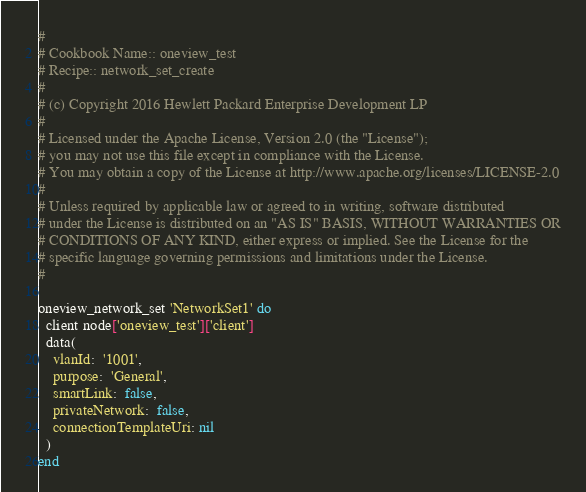Convert code to text. <code><loc_0><loc_0><loc_500><loc_500><_Ruby_>#
# Cookbook Name:: oneview_test
# Recipe:: network_set_create
#
# (c) Copyright 2016 Hewlett Packard Enterprise Development LP
#
# Licensed under the Apache License, Version 2.0 (the "License");
# you may not use this file except in compliance with the License.
# You may obtain a copy of the License at http://www.apache.org/licenses/LICENSE-2.0
#
# Unless required by applicable law or agreed to in writing, software distributed
# under the License is distributed on an "AS IS" BASIS, WITHOUT WARRANTIES OR
# CONDITIONS OF ANY KIND, either express or implied. See the License for the
# specific language governing permissions and limitations under the License.
#

oneview_network_set 'NetworkSet1' do
  client node['oneview_test']['client']
  data(
    vlanId:  '1001',
    purpose:  'General',
    smartLink:  false,
    privateNetwork:  false,
    connectionTemplateUri: nil
  )
end
</code> 